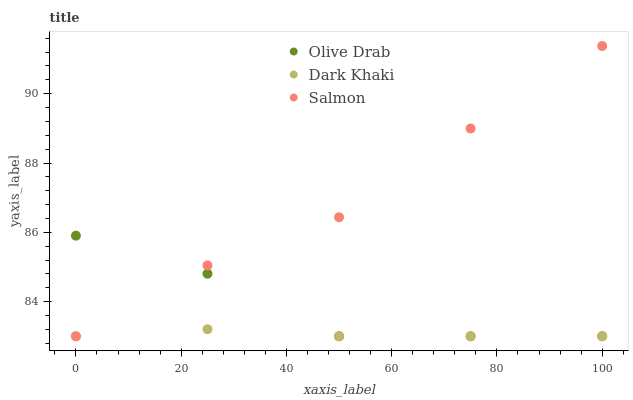Does Dark Khaki have the minimum area under the curve?
Answer yes or no. Yes. Does Salmon have the maximum area under the curve?
Answer yes or no. Yes. Does Olive Drab have the minimum area under the curve?
Answer yes or no. No. Does Olive Drab have the maximum area under the curve?
Answer yes or no. No. Is Dark Khaki the smoothest?
Answer yes or no. Yes. Is Olive Drab the roughest?
Answer yes or no. Yes. Is Salmon the smoothest?
Answer yes or no. No. Is Salmon the roughest?
Answer yes or no. No. Does Dark Khaki have the lowest value?
Answer yes or no. Yes. Does Salmon have the highest value?
Answer yes or no. Yes. Does Olive Drab have the highest value?
Answer yes or no. No. Does Salmon intersect Dark Khaki?
Answer yes or no. Yes. Is Salmon less than Dark Khaki?
Answer yes or no. No. Is Salmon greater than Dark Khaki?
Answer yes or no. No. 